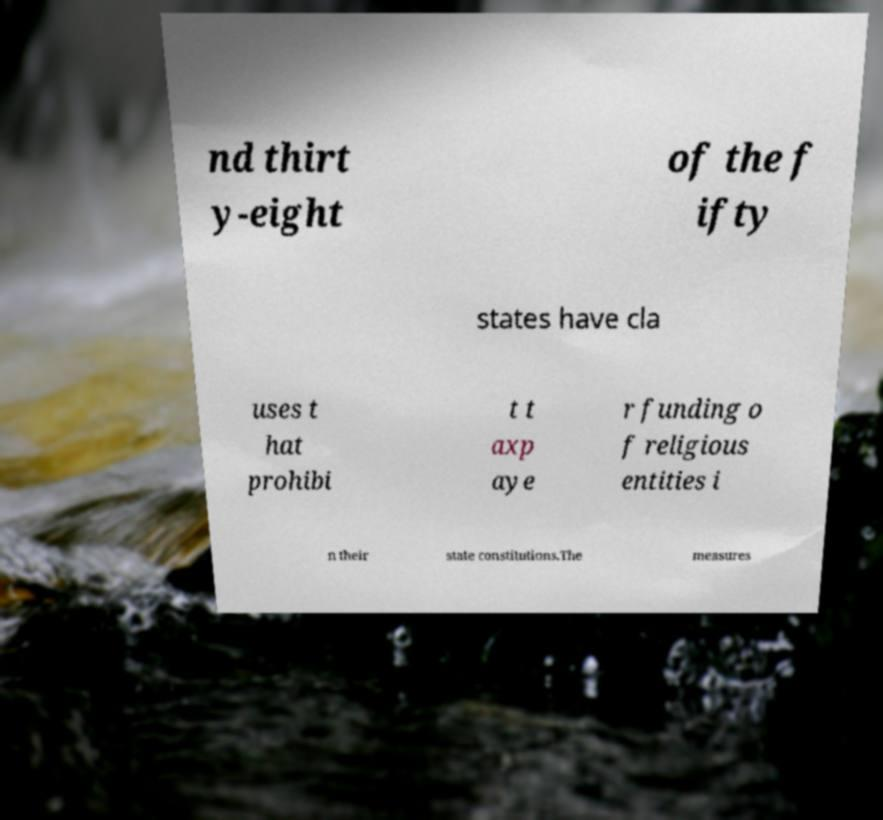Can you accurately transcribe the text from the provided image for me? nd thirt y-eight of the f ifty states have cla uses t hat prohibi t t axp aye r funding o f religious entities i n their state constitutions.The measures 